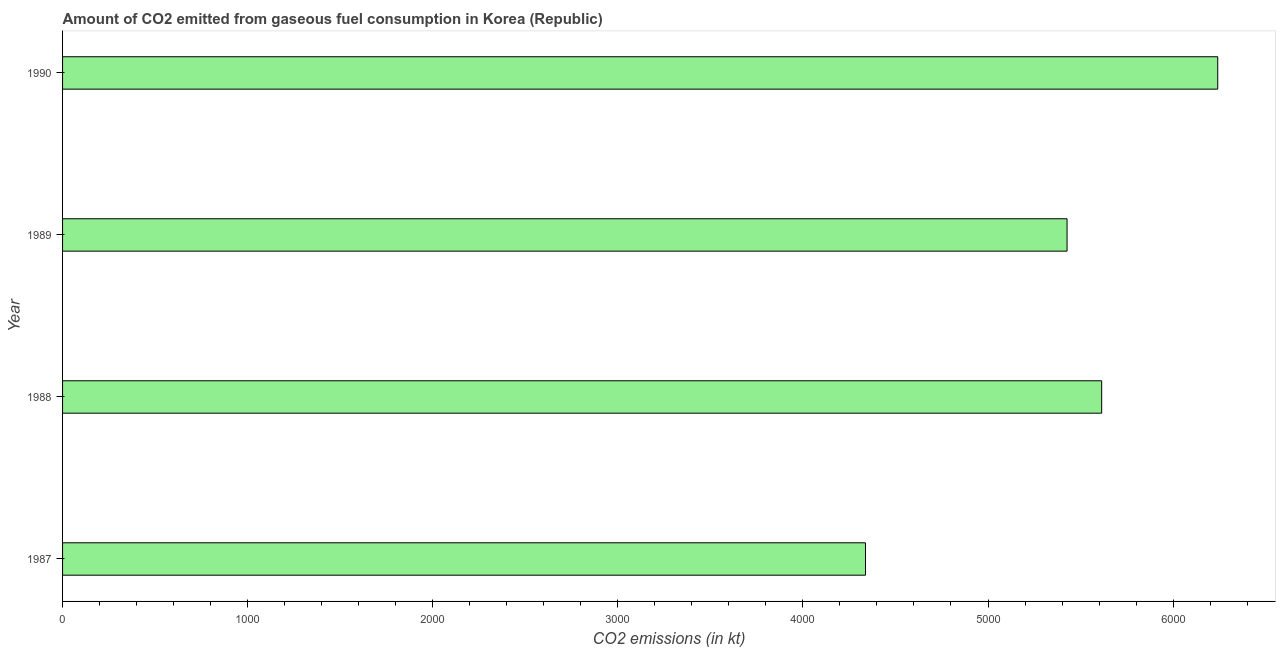What is the title of the graph?
Keep it short and to the point. Amount of CO2 emitted from gaseous fuel consumption in Korea (Republic). What is the label or title of the X-axis?
Make the answer very short. CO2 emissions (in kt). What is the label or title of the Y-axis?
Make the answer very short. Year. What is the co2 emissions from gaseous fuel consumption in 1988?
Keep it short and to the point. 5614.18. Across all years, what is the maximum co2 emissions from gaseous fuel consumption?
Offer a very short reply. 6241.23. Across all years, what is the minimum co2 emissions from gaseous fuel consumption?
Offer a terse response. 4338.06. In which year was the co2 emissions from gaseous fuel consumption maximum?
Your answer should be very brief. 1990. In which year was the co2 emissions from gaseous fuel consumption minimum?
Make the answer very short. 1987. What is the sum of the co2 emissions from gaseous fuel consumption?
Provide a short and direct response. 2.16e+04. What is the difference between the co2 emissions from gaseous fuel consumption in 1987 and 1988?
Your answer should be compact. -1276.12. What is the average co2 emissions from gaseous fuel consumption per year?
Give a very brief answer. 5405.16. What is the median co2 emissions from gaseous fuel consumption?
Keep it short and to the point. 5520.67. In how many years, is the co2 emissions from gaseous fuel consumption greater than 1200 kt?
Your answer should be very brief. 4. Do a majority of the years between 1990 and 1989 (inclusive) have co2 emissions from gaseous fuel consumption greater than 3000 kt?
Give a very brief answer. No. What is the ratio of the co2 emissions from gaseous fuel consumption in 1987 to that in 1990?
Give a very brief answer. 0.69. What is the difference between the highest and the second highest co2 emissions from gaseous fuel consumption?
Offer a very short reply. 627.06. Is the sum of the co2 emissions from gaseous fuel consumption in 1989 and 1990 greater than the maximum co2 emissions from gaseous fuel consumption across all years?
Provide a short and direct response. Yes. What is the difference between the highest and the lowest co2 emissions from gaseous fuel consumption?
Offer a terse response. 1903.17. How many years are there in the graph?
Provide a succinct answer. 4. What is the CO2 emissions (in kt) of 1987?
Your answer should be very brief. 4338.06. What is the CO2 emissions (in kt) of 1988?
Ensure brevity in your answer.  5614.18. What is the CO2 emissions (in kt) of 1989?
Your response must be concise. 5427.16. What is the CO2 emissions (in kt) of 1990?
Offer a terse response. 6241.23. What is the difference between the CO2 emissions (in kt) in 1987 and 1988?
Keep it short and to the point. -1276.12. What is the difference between the CO2 emissions (in kt) in 1987 and 1989?
Your response must be concise. -1089.1. What is the difference between the CO2 emissions (in kt) in 1987 and 1990?
Your answer should be compact. -1903.17. What is the difference between the CO2 emissions (in kt) in 1988 and 1989?
Make the answer very short. 187.02. What is the difference between the CO2 emissions (in kt) in 1988 and 1990?
Your answer should be compact. -627.06. What is the difference between the CO2 emissions (in kt) in 1989 and 1990?
Your answer should be very brief. -814.07. What is the ratio of the CO2 emissions (in kt) in 1987 to that in 1988?
Offer a terse response. 0.77. What is the ratio of the CO2 emissions (in kt) in 1987 to that in 1989?
Give a very brief answer. 0.8. What is the ratio of the CO2 emissions (in kt) in 1987 to that in 1990?
Your response must be concise. 0.69. What is the ratio of the CO2 emissions (in kt) in 1988 to that in 1989?
Offer a very short reply. 1.03. What is the ratio of the CO2 emissions (in kt) in 1988 to that in 1990?
Your answer should be very brief. 0.9. What is the ratio of the CO2 emissions (in kt) in 1989 to that in 1990?
Offer a very short reply. 0.87. 